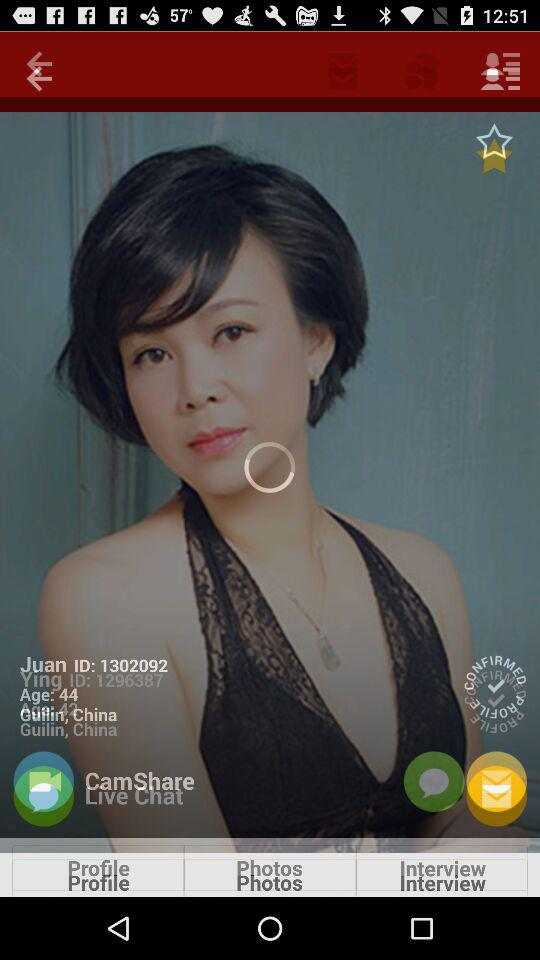Which country does Juan belong to? Juan belongs to China. 